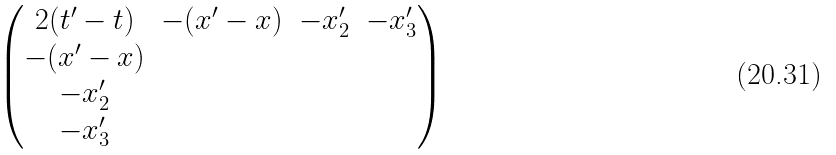Convert formula to latex. <formula><loc_0><loc_0><loc_500><loc_500>\begin{pmatrix} 2 ( t ^ { \prime } - t ) & - ( x ^ { \prime } - x ) & - x _ { 2 } ^ { \prime } & - x _ { 3 } ^ { \prime } \\ - ( x ^ { \prime } - x ) & & & \\ - x _ { 2 } ^ { \prime } & & & \\ - x _ { 3 } ^ { \prime } & & & \end{pmatrix}</formula> 